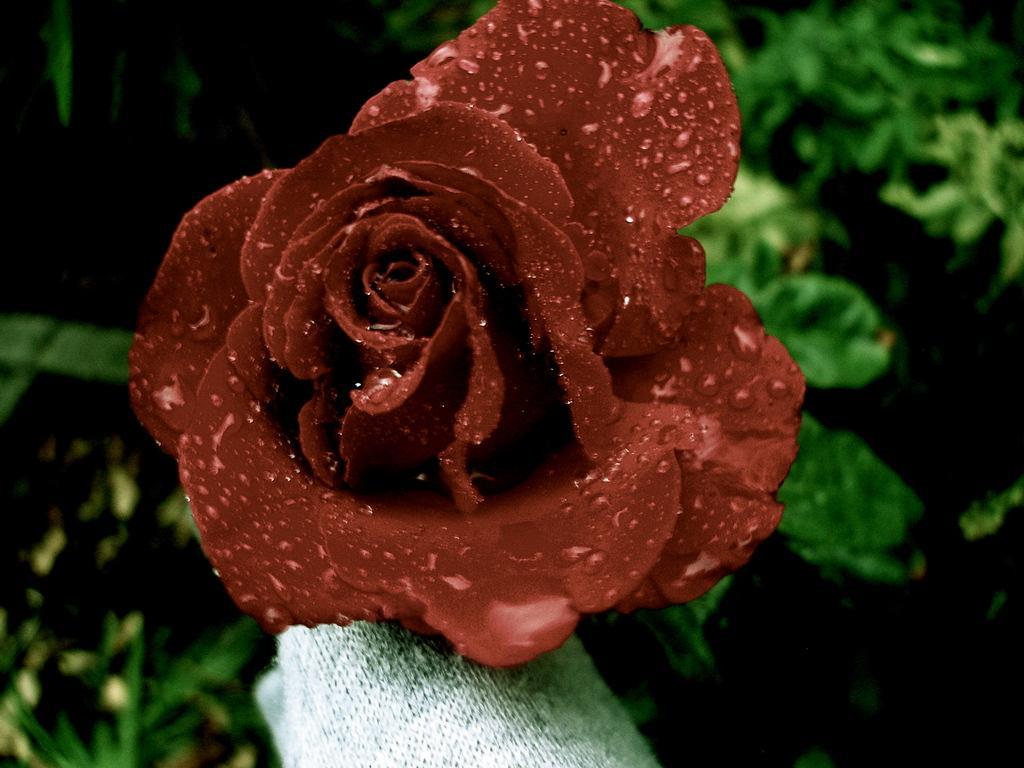In one or two sentences, can you explain what this image depicts? This image is taken outdoors. In the background there are a few plants with green leaves. In the middle of the image there is a beautiful rose which is dark red in color. At the bottom of the image there is a woolen cloth. 